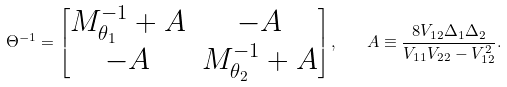Convert formula to latex. <formula><loc_0><loc_0><loc_500><loc_500>\Theta ^ { - 1 } = \begin{bmatrix} M _ { \theta _ { 1 } } ^ { - 1 } + A & - A \\ - A & M _ { \theta _ { 2 } } ^ { - 1 } + A \end{bmatrix} , \quad A \equiv \frac { 8 V _ { 1 2 } \Delta _ { 1 } \Delta _ { 2 } } { V _ { 1 1 } V _ { 2 2 } - V _ { 1 2 } ^ { 2 } } .</formula> 